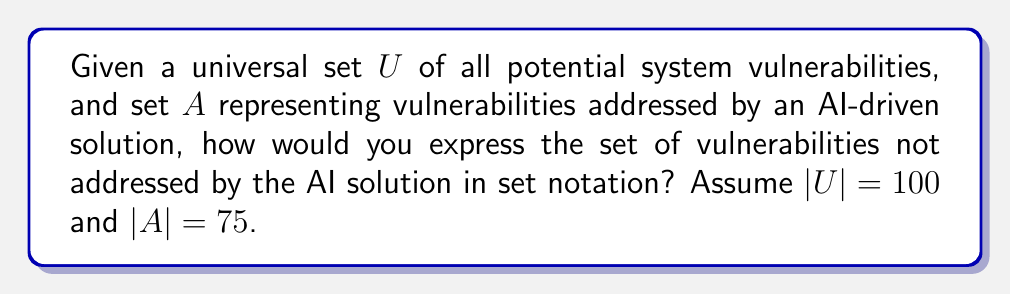Give your solution to this math problem. To solve this problem, we need to understand the concept of set complement:

1. The complement of a set $A$ with respect to a universal set $U$ is denoted as $A^c$ or $\overline{A}$.

2. $A^c$ contains all elements in $U$ that are not in $A$.

3. In set notation, this is expressed as: $A^c = \{x \in U : x \notin A\}$

4. We can also calculate the cardinality (size) of the complement set:
   $|A^c| = |U| - |A|$

In this case:
- $U$ is the universal set of all potential system vulnerabilities
- $A$ is the set of vulnerabilities addressed by the AI solution
- We want to find $A^c$, which represents vulnerabilities not addressed by the AI solution

We can calculate the size of $A^c$:
$|A^c| = |U| - |A| = 100 - 75 = 25$

This means there are 25 vulnerabilities not addressed by the AI solution.
Answer: $A^c = \{x \in U : x \notin A\}$, where $|A^c| = 25$ 